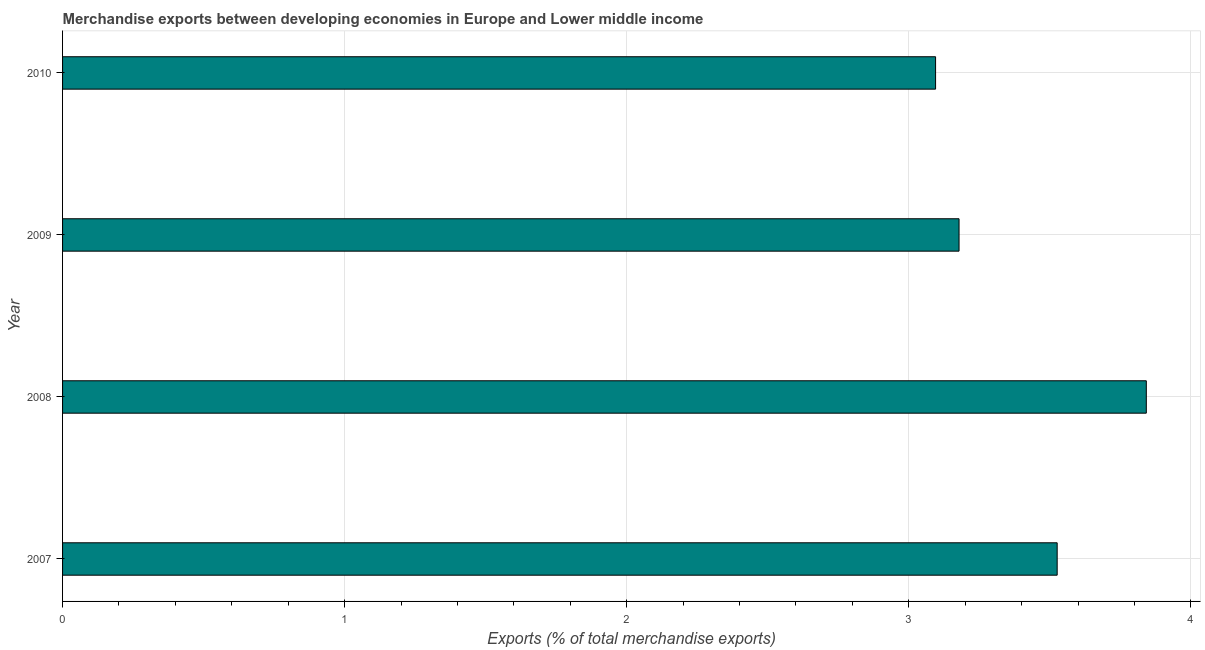Does the graph contain grids?
Your answer should be compact. Yes. What is the title of the graph?
Provide a short and direct response. Merchandise exports between developing economies in Europe and Lower middle income. What is the label or title of the X-axis?
Give a very brief answer. Exports (% of total merchandise exports). What is the label or title of the Y-axis?
Offer a very short reply. Year. What is the merchandise exports in 2007?
Make the answer very short. 3.53. Across all years, what is the maximum merchandise exports?
Your answer should be compact. 3.84. Across all years, what is the minimum merchandise exports?
Keep it short and to the point. 3.1. In which year was the merchandise exports maximum?
Your answer should be very brief. 2008. What is the sum of the merchandise exports?
Offer a terse response. 13.64. What is the difference between the merchandise exports in 2008 and 2009?
Give a very brief answer. 0.66. What is the average merchandise exports per year?
Your answer should be very brief. 3.41. What is the median merchandise exports?
Ensure brevity in your answer.  3.35. What is the ratio of the merchandise exports in 2008 to that in 2009?
Your answer should be compact. 1.21. What is the difference between the highest and the second highest merchandise exports?
Your response must be concise. 0.32. In how many years, is the merchandise exports greater than the average merchandise exports taken over all years?
Provide a short and direct response. 2. How many bars are there?
Offer a very short reply. 4. What is the difference between two consecutive major ticks on the X-axis?
Give a very brief answer. 1. Are the values on the major ticks of X-axis written in scientific E-notation?
Make the answer very short. No. What is the Exports (% of total merchandise exports) of 2007?
Provide a succinct answer. 3.53. What is the Exports (% of total merchandise exports) of 2008?
Your answer should be very brief. 3.84. What is the Exports (% of total merchandise exports) in 2009?
Your answer should be compact. 3.18. What is the Exports (% of total merchandise exports) of 2010?
Provide a succinct answer. 3.1. What is the difference between the Exports (% of total merchandise exports) in 2007 and 2008?
Ensure brevity in your answer.  -0.32. What is the difference between the Exports (% of total merchandise exports) in 2007 and 2009?
Keep it short and to the point. 0.35. What is the difference between the Exports (% of total merchandise exports) in 2007 and 2010?
Your answer should be very brief. 0.43. What is the difference between the Exports (% of total merchandise exports) in 2008 and 2009?
Provide a succinct answer. 0.66. What is the difference between the Exports (% of total merchandise exports) in 2008 and 2010?
Make the answer very short. 0.75. What is the difference between the Exports (% of total merchandise exports) in 2009 and 2010?
Make the answer very short. 0.08. What is the ratio of the Exports (% of total merchandise exports) in 2007 to that in 2008?
Ensure brevity in your answer.  0.92. What is the ratio of the Exports (% of total merchandise exports) in 2007 to that in 2009?
Keep it short and to the point. 1.11. What is the ratio of the Exports (% of total merchandise exports) in 2007 to that in 2010?
Provide a succinct answer. 1.14. What is the ratio of the Exports (% of total merchandise exports) in 2008 to that in 2009?
Keep it short and to the point. 1.21. What is the ratio of the Exports (% of total merchandise exports) in 2008 to that in 2010?
Your answer should be very brief. 1.24. 